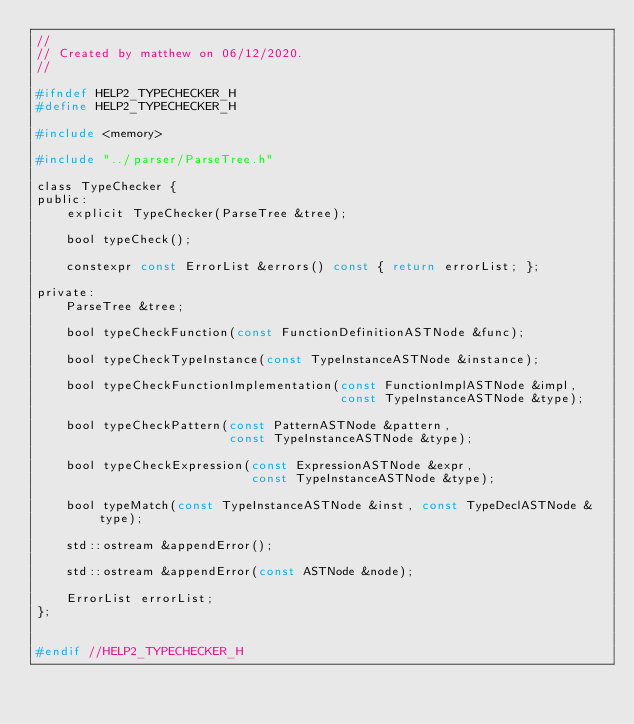Convert code to text. <code><loc_0><loc_0><loc_500><loc_500><_C_>//
// Created by matthew on 06/12/2020.
//

#ifndef HELP2_TYPECHECKER_H
#define HELP2_TYPECHECKER_H

#include <memory>

#include "../parser/ParseTree.h"

class TypeChecker {
public:
    explicit TypeChecker(ParseTree &tree);

    bool typeCheck();

    constexpr const ErrorList &errors() const { return errorList; };

private:
    ParseTree &tree;

    bool typeCheckFunction(const FunctionDefinitionASTNode &func);

    bool typeCheckTypeInstance(const TypeInstanceASTNode &instance);

    bool typeCheckFunctionImplementation(const FunctionImplASTNode &impl,
                                         const TypeInstanceASTNode &type);

    bool typeCheckPattern(const PatternASTNode &pattern,
                          const TypeInstanceASTNode &type);

    bool typeCheckExpression(const ExpressionASTNode &expr,
                             const TypeInstanceASTNode &type);

    bool typeMatch(const TypeInstanceASTNode &inst, const TypeDeclASTNode &type);

    std::ostream &appendError();

    std::ostream &appendError(const ASTNode &node);

    ErrorList errorList;
};


#endif //HELP2_TYPECHECKER_H
</code> 